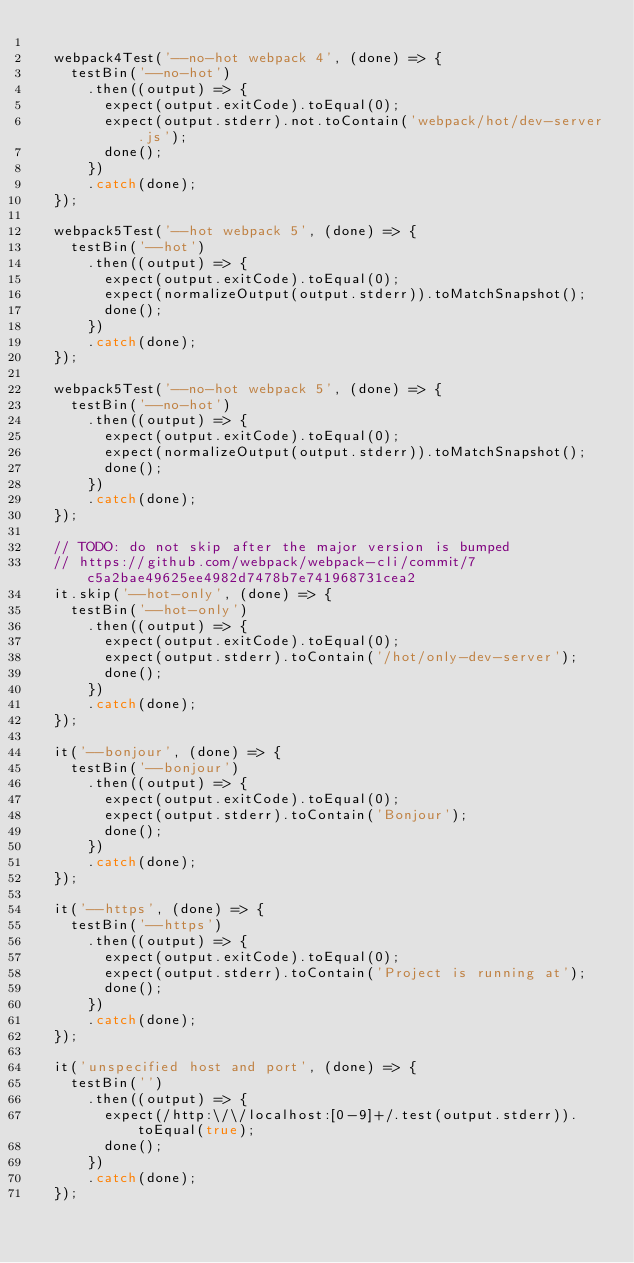Convert code to text. <code><loc_0><loc_0><loc_500><loc_500><_JavaScript_>
  webpack4Test('--no-hot webpack 4', (done) => {
    testBin('--no-hot')
      .then((output) => {
        expect(output.exitCode).toEqual(0);
        expect(output.stderr).not.toContain('webpack/hot/dev-server.js');
        done();
      })
      .catch(done);
  });

  webpack5Test('--hot webpack 5', (done) => {
    testBin('--hot')
      .then((output) => {
        expect(output.exitCode).toEqual(0);
        expect(normalizeOutput(output.stderr)).toMatchSnapshot();
        done();
      })
      .catch(done);
  });

  webpack5Test('--no-hot webpack 5', (done) => {
    testBin('--no-hot')
      .then((output) => {
        expect(output.exitCode).toEqual(0);
        expect(normalizeOutput(output.stderr)).toMatchSnapshot();
        done();
      })
      .catch(done);
  });

  // TODO: do not skip after the major version is bumped
  // https://github.com/webpack/webpack-cli/commit/7c5a2bae49625ee4982d7478b7e741968731cea2
  it.skip('--hot-only', (done) => {
    testBin('--hot-only')
      .then((output) => {
        expect(output.exitCode).toEqual(0);
        expect(output.stderr).toContain('/hot/only-dev-server');
        done();
      })
      .catch(done);
  });

  it('--bonjour', (done) => {
    testBin('--bonjour')
      .then((output) => {
        expect(output.exitCode).toEqual(0);
        expect(output.stderr).toContain('Bonjour');
        done();
      })
      .catch(done);
  });

  it('--https', (done) => {
    testBin('--https')
      .then((output) => {
        expect(output.exitCode).toEqual(0);
        expect(output.stderr).toContain('Project is running at');
        done();
      })
      .catch(done);
  });

  it('unspecified host and port', (done) => {
    testBin('')
      .then((output) => {
        expect(/http:\/\/localhost:[0-9]+/.test(output.stderr)).toEqual(true);
        done();
      })
      .catch(done);
  });
</code> 